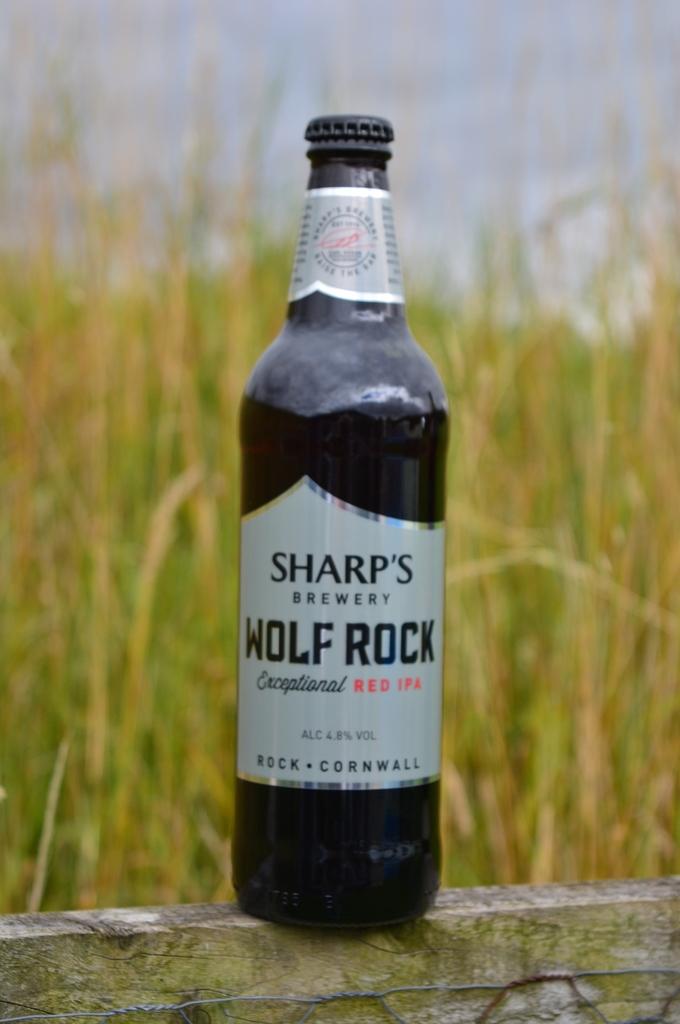Which brewery makes the wolf rock beverage?
Ensure brevity in your answer.  Sharp's. What kind of ipa is it?
Provide a short and direct response. Red. 